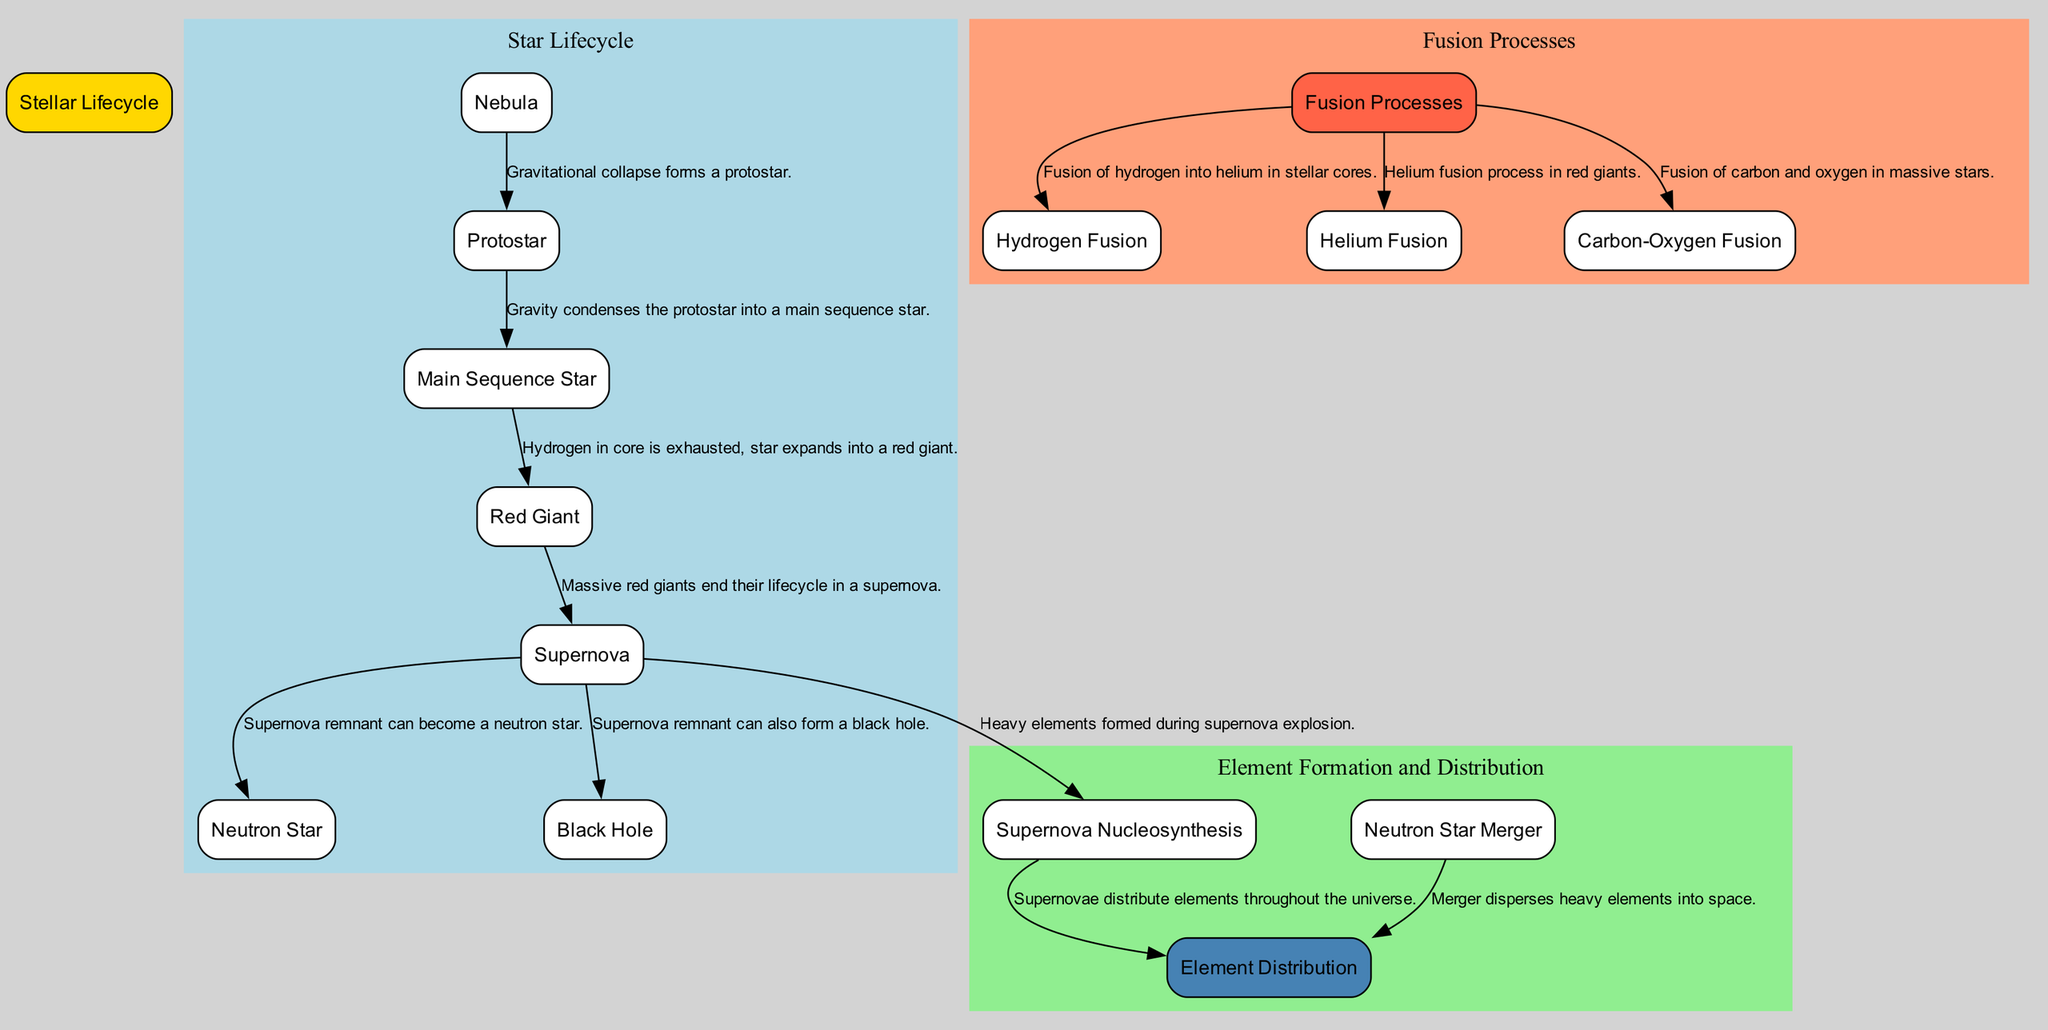What is the first stage in the stellar lifecycle? The diagram shows the sequence of star formation, starting from "Nebula" as the first stage where stars are born.
Answer: Nebula What element is primarily produced during hydrogen fusion? The diagram indicates that during the hydrogen fusion process, hydrogen is converted to helium.
Answer: Helium How many major fusion processes are depicted in the diagram? By counting the nodes under "Fusion Processes," there are three processes: hydrogen fusion, helium fusion, and carbon-oxygen fusion.
Answer: 3 What happens to a massive red giant at the end of its lifecycle? The diagram shows that a massive red giant culminates its lifecycle with a supernova explosion.
Answer: Supernova Which process involves the formation of elements heavier than iron? The diagram clearly specifies that "Supernova Nucleosynthesis" is responsible for the creation of elements heavier than iron during a supernova event.
Answer: Supernova Nucleosynthesis What does a neutron star merger produce? According to the diagram, a neutron star merger is indicated to produce heavy elements like gold and platinum during the event.
Answer: Heavy elements Which node is linked to both the neutron star and black hole? Following the connections in the diagram, the "Supernova" nodes lead to both "Neutron Star" and "Black Hole."
Answer: Supernova How are elements distributed throughout the universe according to the diagram? The diagram specifies that both "Supernova Nucleosynthesis" and "Neutron Star Merger" contribute to the distribution of elements throughout the universe.
Answer: Element Distribution What color represents the "Stellar Lifecycle" in the diagram? The diagram uses a light blue color for the nodes related to the "Stellar Lifecycle."
Answer: Light Blue 